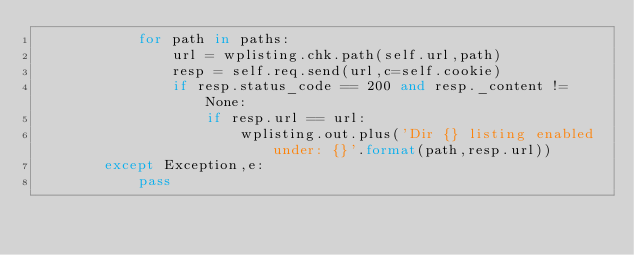<code> <loc_0><loc_0><loc_500><loc_500><_Python_>			for path in paths:
				url = wplisting.chk.path(self.url,path)
				resp = self.req.send(url,c=self.cookie)
				if resp.status_code == 200 and resp._content != None:
					if resp.url == url:
						wplisting.out.plus('Dir {} listing enabled under: {}'.format(path,resp.url))
		except Exception,e:
			pass</code> 